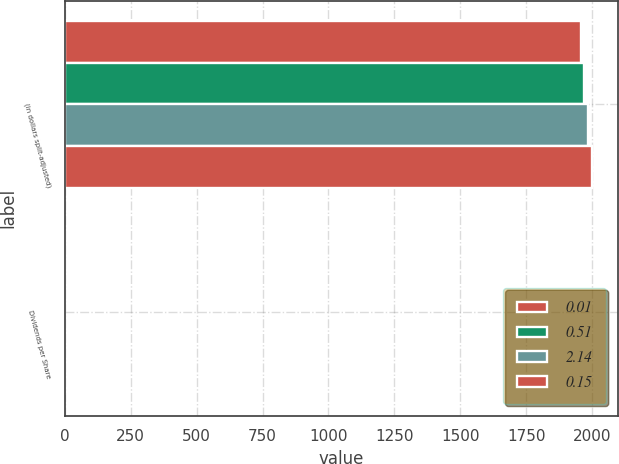Convert chart. <chart><loc_0><loc_0><loc_500><loc_500><stacked_bar_chart><ecel><fcel>(in dollars split-adjusted)<fcel>Dividends per Share<nl><fcel>0.01<fcel>1956<fcel>0.01<nl><fcel>0.51<fcel>1970<fcel>0.04<nl><fcel>2.14<fcel>1984<fcel>0.15<nl><fcel>0.15<fcel>1998<fcel>0.51<nl></chart> 